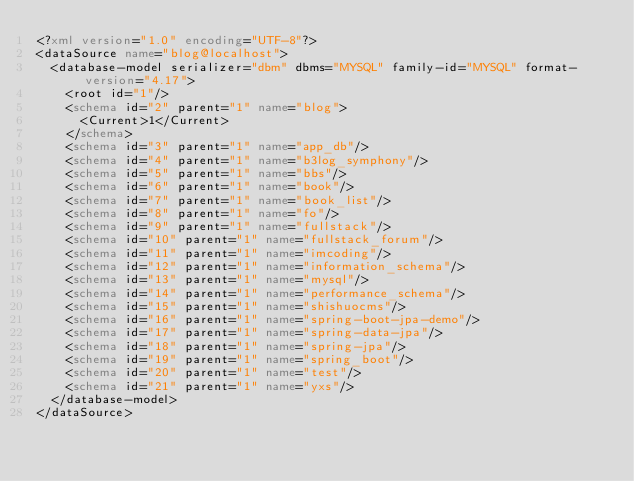Convert code to text. <code><loc_0><loc_0><loc_500><loc_500><_XML_><?xml version="1.0" encoding="UTF-8"?>
<dataSource name="blog@localhost">
  <database-model serializer="dbm" dbms="MYSQL" family-id="MYSQL" format-version="4.17">
    <root id="1"/>
    <schema id="2" parent="1" name="blog">
      <Current>1</Current>
    </schema>
    <schema id="3" parent="1" name="app_db"/>
    <schema id="4" parent="1" name="b3log_symphony"/>
    <schema id="5" parent="1" name="bbs"/>
    <schema id="6" parent="1" name="book"/>
    <schema id="7" parent="1" name="book_list"/>
    <schema id="8" parent="1" name="fo"/>
    <schema id="9" parent="1" name="fullstack"/>
    <schema id="10" parent="1" name="fullstack_forum"/>
    <schema id="11" parent="1" name="imcoding"/>
    <schema id="12" parent="1" name="information_schema"/>
    <schema id="13" parent="1" name="mysql"/>
    <schema id="14" parent="1" name="performance_schema"/>
    <schema id="15" parent="1" name="shishuocms"/>
    <schema id="16" parent="1" name="spring-boot-jpa-demo"/>
    <schema id="17" parent="1" name="spring-data-jpa"/>
    <schema id="18" parent="1" name="spring-jpa"/>
    <schema id="19" parent="1" name="spring_boot"/>
    <schema id="20" parent="1" name="test"/>
    <schema id="21" parent="1" name="yxs"/>
  </database-model>
</dataSource></code> 